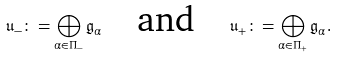<formula> <loc_0><loc_0><loc_500><loc_500>\mathfrak { u } _ { - } \colon = \bigoplus _ { \alpha \in \Pi _ { - } } \mathfrak { g } _ { \alpha } \quad \text {and} \quad \mathfrak { u } _ { + } \colon = \bigoplus _ { \alpha \in \Pi _ { + } } \mathfrak { g } _ { \alpha } .</formula> 